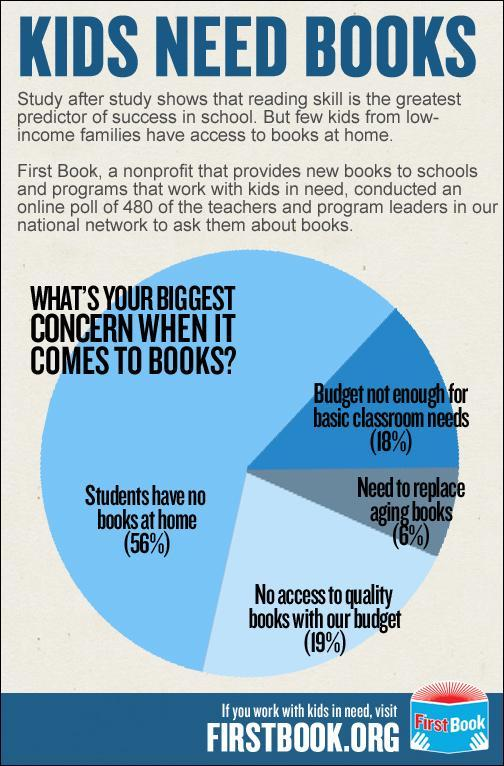What is written on the book image
Answer the question with a short phrase. FirstBook What is the least concern when it comes to books need to replace aging books What % need to replace aging books 6% What is the total % of students who have no books at home and who need to replace aging books 62 